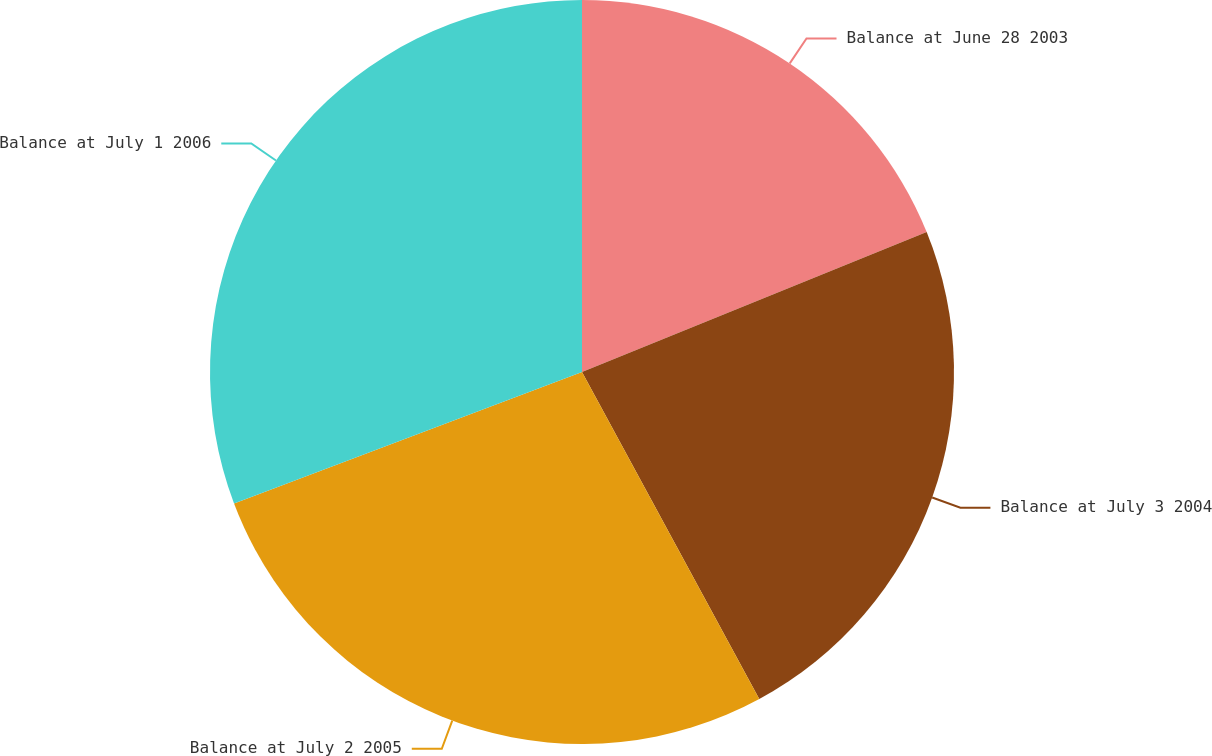<chart> <loc_0><loc_0><loc_500><loc_500><pie_chart><fcel>Balance at June 28 2003<fcel>Balance at July 3 2004<fcel>Balance at July 2 2005<fcel>Balance at July 1 2006<nl><fcel>18.86%<fcel>23.23%<fcel>27.15%<fcel>30.75%<nl></chart> 